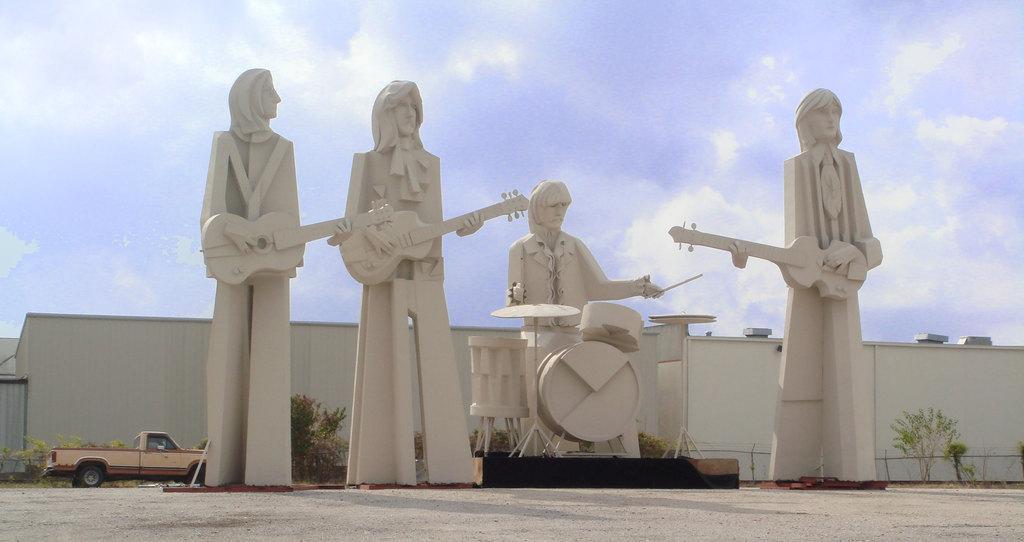Please provide a concise description of this image. In this we can see sculptures of people playing musical instruments, there is a vehicle, plants, houses, also we can see the sky. 